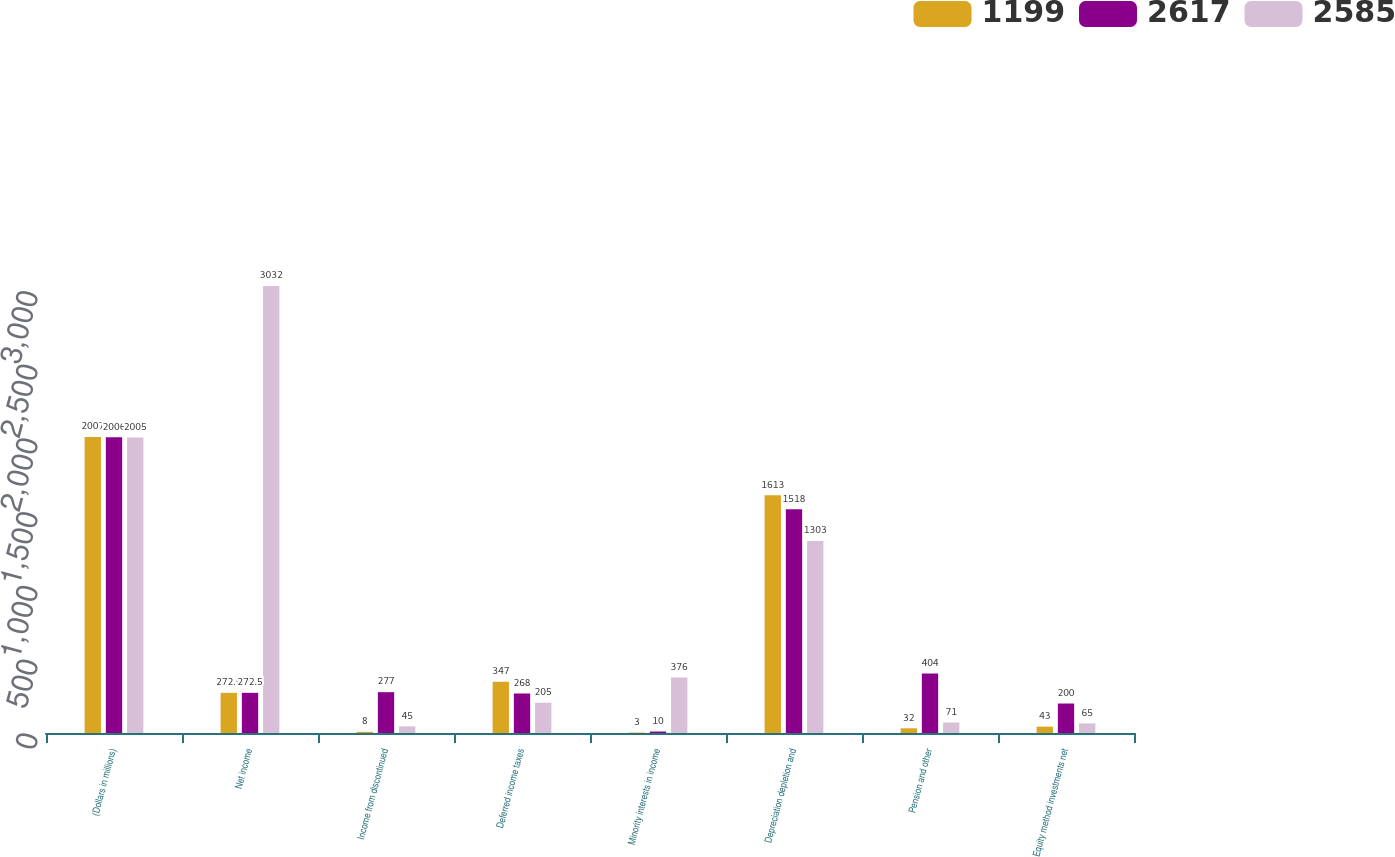<chart> <loc_0><loc_0><loc_500><loc_500><stacked_bar_chart><ecel><fcel>(Dollars in millions)<fcel>Net income<fcel>Income from discontinued<fcel>Deferred income taxes<fcel>Minority interests in income<fcel>Depreciation depletion and<fcel>Pension and other<fcel>Equity method investments net<nl><fcel>1199<fcel>2007<fcel>272.5<fcel>8<fcel>347<fcel>3<fcel>1613<fcel>32<fcel>43<nl><fcel>2617<fcel>2006<fcel>272.5<fcel>277<fcel>268<fcel>10<fcel>1518<fcel>404<fcel>200<nl><fcel>2585<fcel>2005<fcel>3032<fcel>45<fcel>205<fcel>376<fcel>1303<fcel>71<fcel>65<nl></chart> 